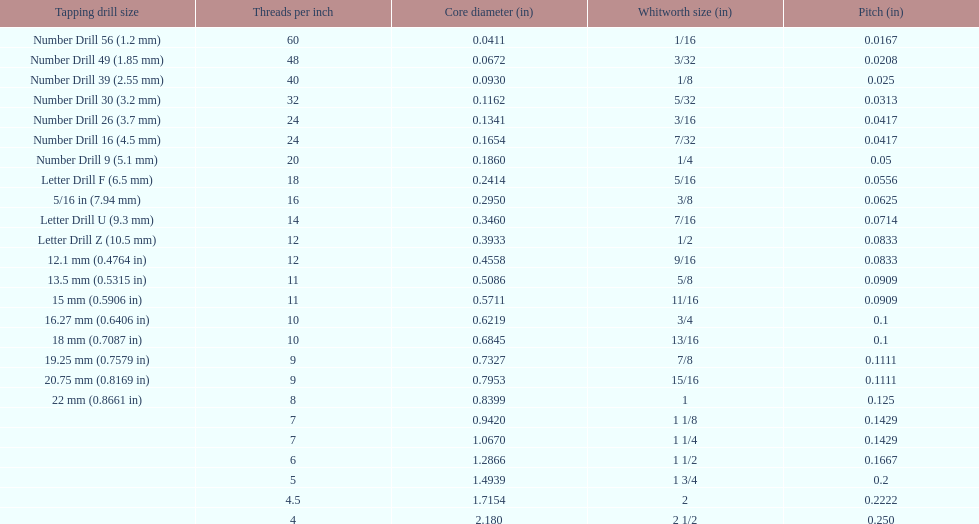What is the core diameter of the last whitworth thread size? 2.180. 